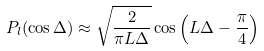<formula> <loc_0><loc_0><loc_500><loc_500>P _ { l } ( \cos \Delta ) \approx \sqrt { \frac { 2 } { \pi L \Delta } } \cos \left ( L \Delta - \frac { \pi } { 4 } \right )</formula> 